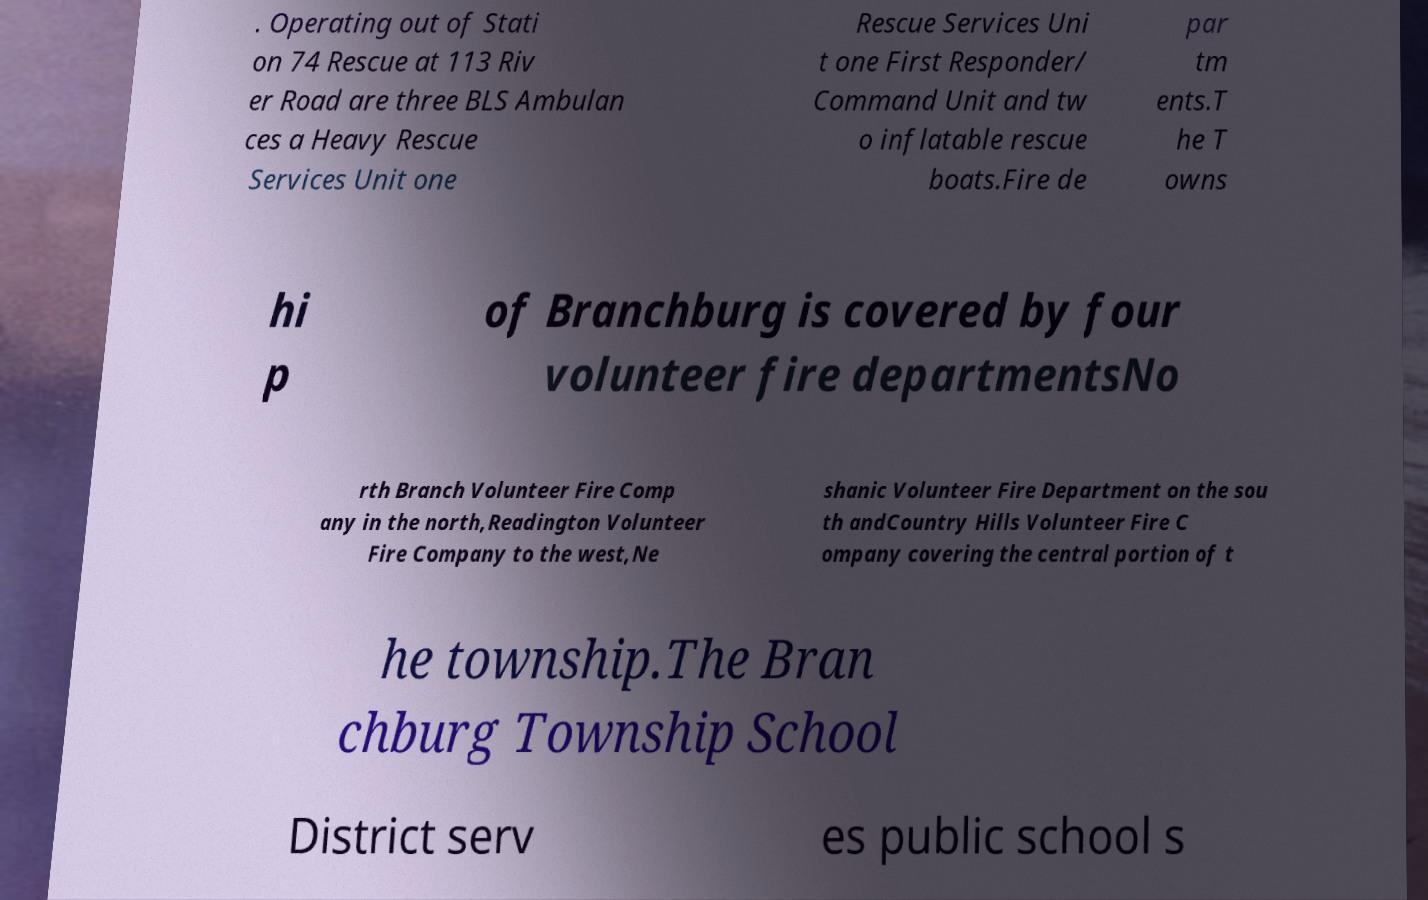I need the written content from this picture converted into text. Can you do that? . Operating out of Stati on 74 Rescue at 113 Riv er Road are three BLS Ambulan ces a Heavy Rescue Services Unit one Rescue Services Uni t one First Responder/ Command Unit and tw o inflatable rescue boats.Fire de par tm ents.T he T owns hi p of Branchburg is covered by four volunteer fire departmentsNo rth Branch Volunteer Fire Comp any in the north,Readington Volunteer Fire Company to the west,Ne shanic Volunteer Fire Department on the sou th andCountry Hills Volunteer Fire C ompany covering the central portion of t he township.The Bran chburg Township School District serv es public school s 